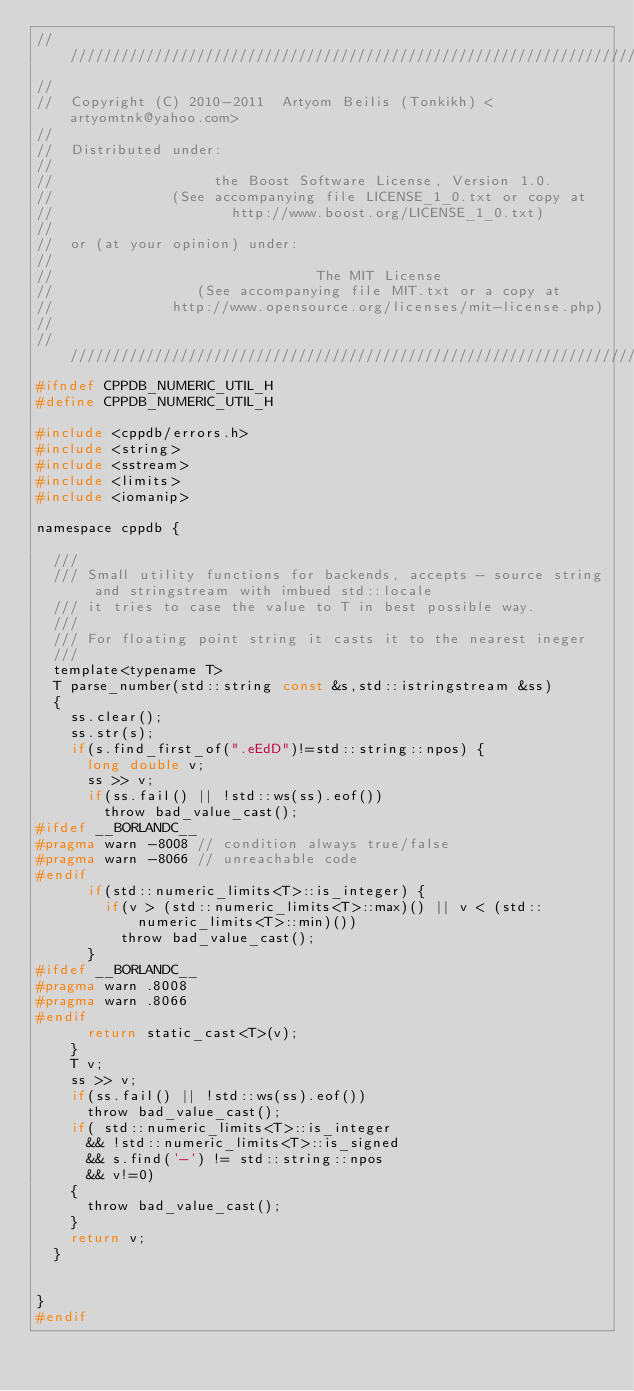Convert code to text. <code><loc_0><loc_0><loc_500><loc_500><_C_>///////////////////////////////////////////////////////////////////////////////
//                                                                             
//  Copyright (C) 2010-2011  Artyom Beilis (Tonkikh) <artyomtnk@yahoo.com>     
//                                                                             
//  Distributed under:
//
//                   the Boost Software License, Version 1.0.
//              (See accompanying file LICENSE_1_0.txt or copy at 
//                     http://www.boost.org/LICENSE_1_0.txt)
//
//  or (at your opinion) under:
//
//                               The MIT License
//                 (See accompanying file MIT.txt or a copy at
//              http://www.opensource.org/licenses/mit-license.php)
//
///////////////////////////////////////////////////////////////////////////////
#ifndef CPPDB_NUMERIC_UTIL_H
#define CPPDB_NUMERIC_UTIL_H

#include <cppdb/errors.h>
#include <string>
#include <sstream>
#include <limits>
#include <iomanip>

namespace cppdb {

	///
	/// Small utility functions for backends, accepts - source string and stringstream with imbued std::locale
	/// it tries to case the value to T in best possible way.
	///
	/// For floating point string it casts it to the nearest ineger
	///
	template<typename T>
	T parse_number(std::string const &s,std::istringstream &ss)
	{
		ss.clear();
		ss.str(s);
		if(s.find_first_of(".eEdD")!=std::string::npos) {
			long double v;
			ss >> v;
			if(ss.fail() || !std::ws(ss).eof())
				throw bad_value_cast();
#ifdef __BORLANDC__
#pragma warn -8008 // condition always true/false
#pragma warn -8066 // unreachable code
#endif
			if(std::numeric_limits<T>::is_integer) {
				if(v > (std::numeric_limits<T>::max)() || v < (std::numeric_limits<T>::min)())
					throw bad_value_cast();
			}
#ifdef __BORLANDC__
#pragma warn .8008
#pragma warn .8066
#endif
			return static_cast<T>(v);
		}
		T v;
		ss >> v;
		if(ss.fail() || !std::ws(ss).eof()) 
			throw bad_value_cast();
		if(	std::numeric_limits<T>::is_integer 
			&& !std::numeric_limits<T>::is_signed 
			&& s.find('-') != std::string::npos 
			&& v!=0) 
		{
			throw bad_value_cast();
		}
		return v;
	}


}
#endif
</code> 